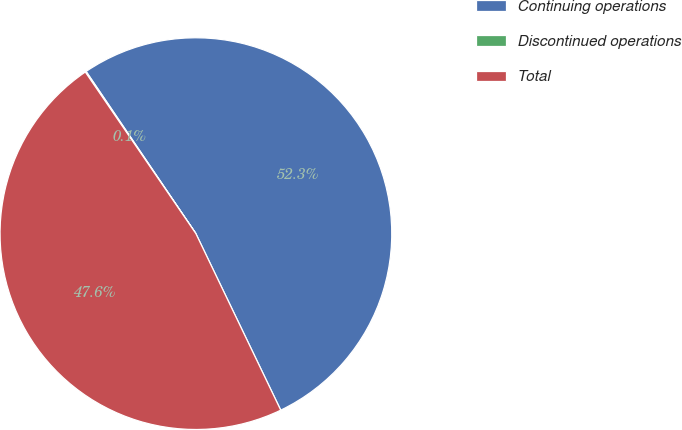Convert chart. <chart><loc_0><loc_0><loc_500><loc_500><pie_chart><fcel>Continuing operations<fcel>Discontinued operations<fcel>Total<nl><fcel>52.34%<fcel>0.08%<fcel>47.58%<nl></chart> 